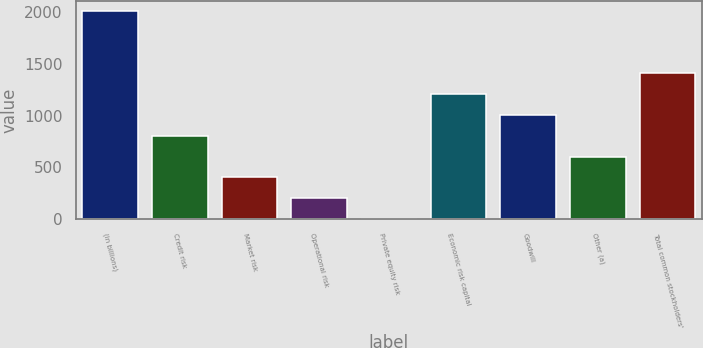<chart> <loc_0><loc_0><loc_500><loc_500><bar_chart><fcel>(in billions)<fcel>Credit risk<fcel>Market risk<fcel>Operational risk<fcel>Private equity risk<fcel>Economic risk capital<fcel>Goodwill<fcel>Other (a)<fcel>Total common stockholders'<nl><fcel>2007<fcel>805.02<fcel>404.36<fcel>204.03<fcel>3.7<fcel>1205.68<fcel>1005.35<fcel>604.69<fcel>1406.01<nl></chart> 